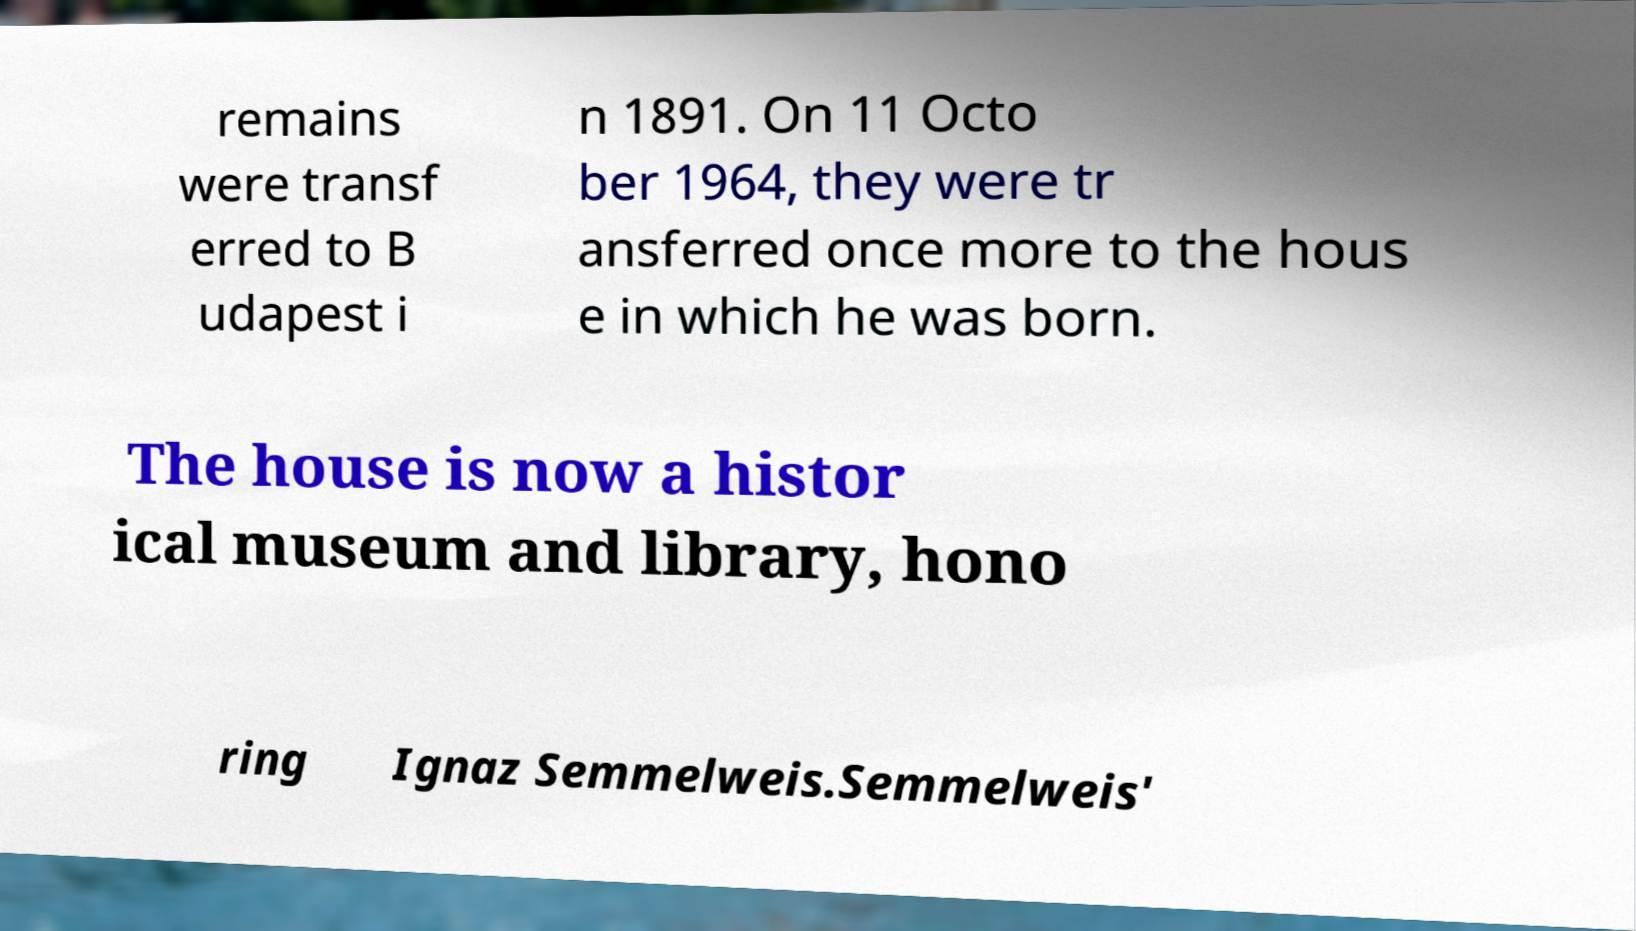What messages or text are displayed in this image? I need them in a readable, typed format. remains were transf erred to B udapest i n 1891. On 11 Octo ber 1964, they were tr ansferred once more to the hous e in which he was born. The house is now a histor ical museum and library, hono ring Ignaz Semmelweis.Semmelweis' 